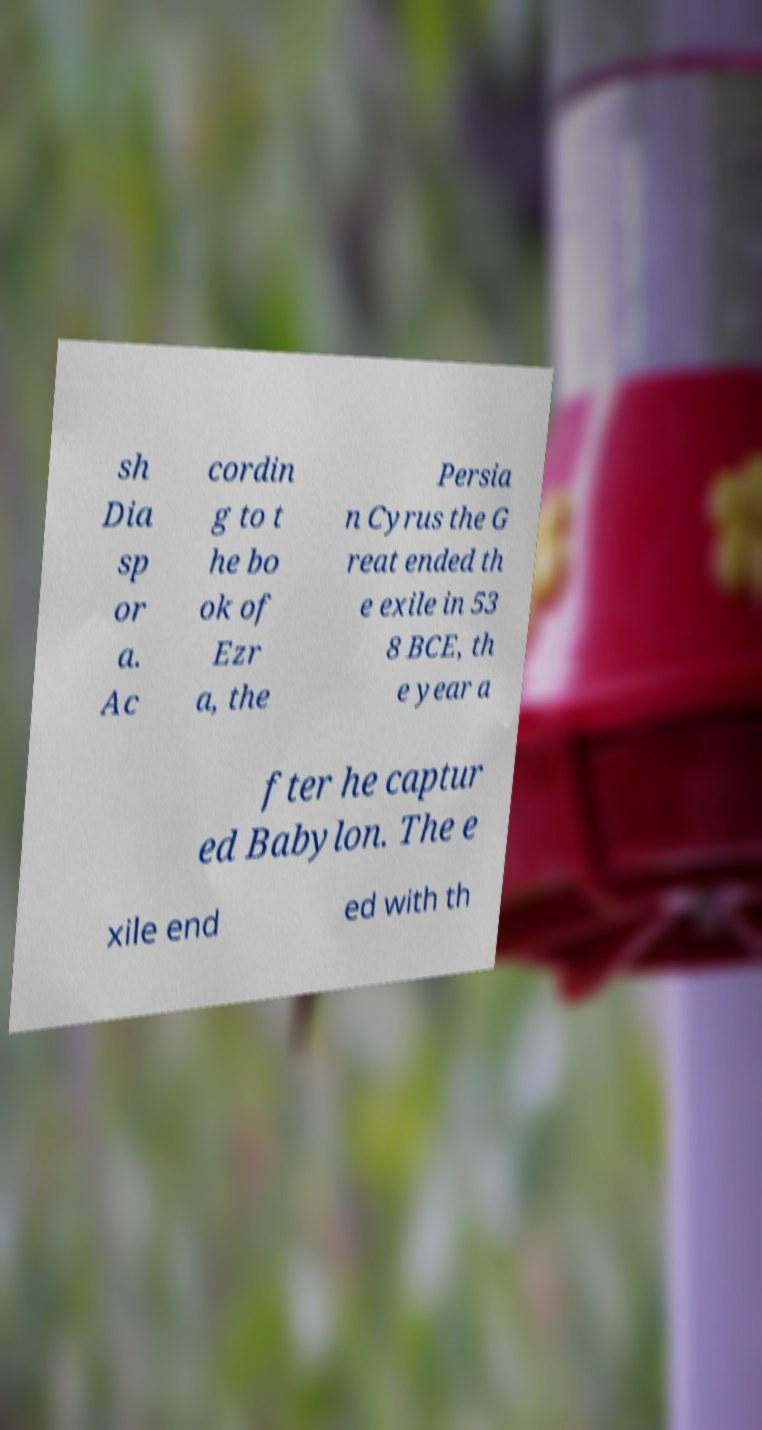Can you accurately transcribe the text from the provided image for me? sh Dia sp or a. Ac cordin g to t he bo ok of Ezr a, the Persia n Cyrus the G reat ended th e exile in 53 8 BCE, th e year a fter he captur ed Babylon. The e xile end ed with th 